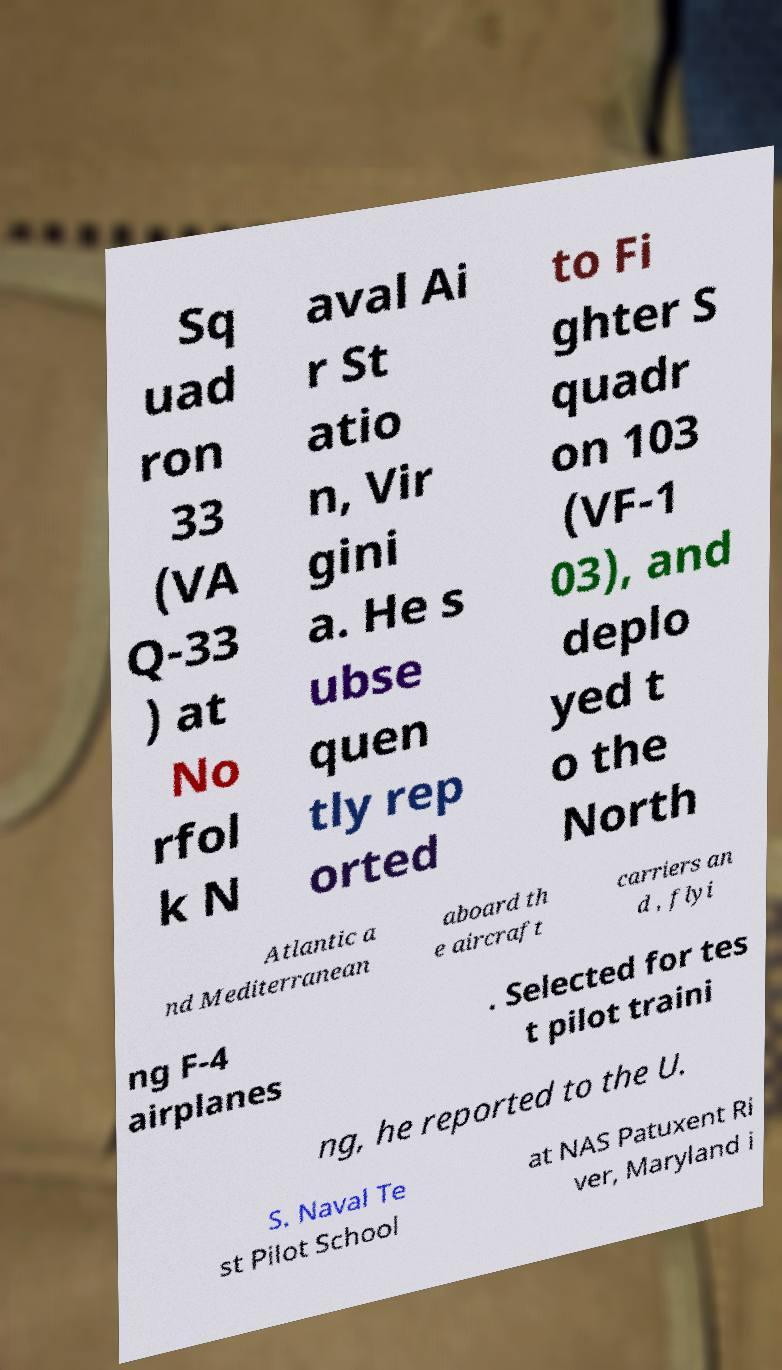For documentation purposes, I need the text within this image transcribed. Could you provide that? Sq uad ron 33 (VA Q-33 ) at No rfol k N aval Ai r St atio n, Vir gini a. He s ubse quen tly rep orted to Fi ghter S quadr on 103 (VF-1 03), and deplo yed t o the North Atlantic a nd Mediterranean aboard th e aircraft carriers an d , flyi ng F-4 airplanes . Selected for tes t pilot traini ng, he reported to the U. S. Naval Te st Pilot School at NAS Patuxent Ri ver, Maryland i 